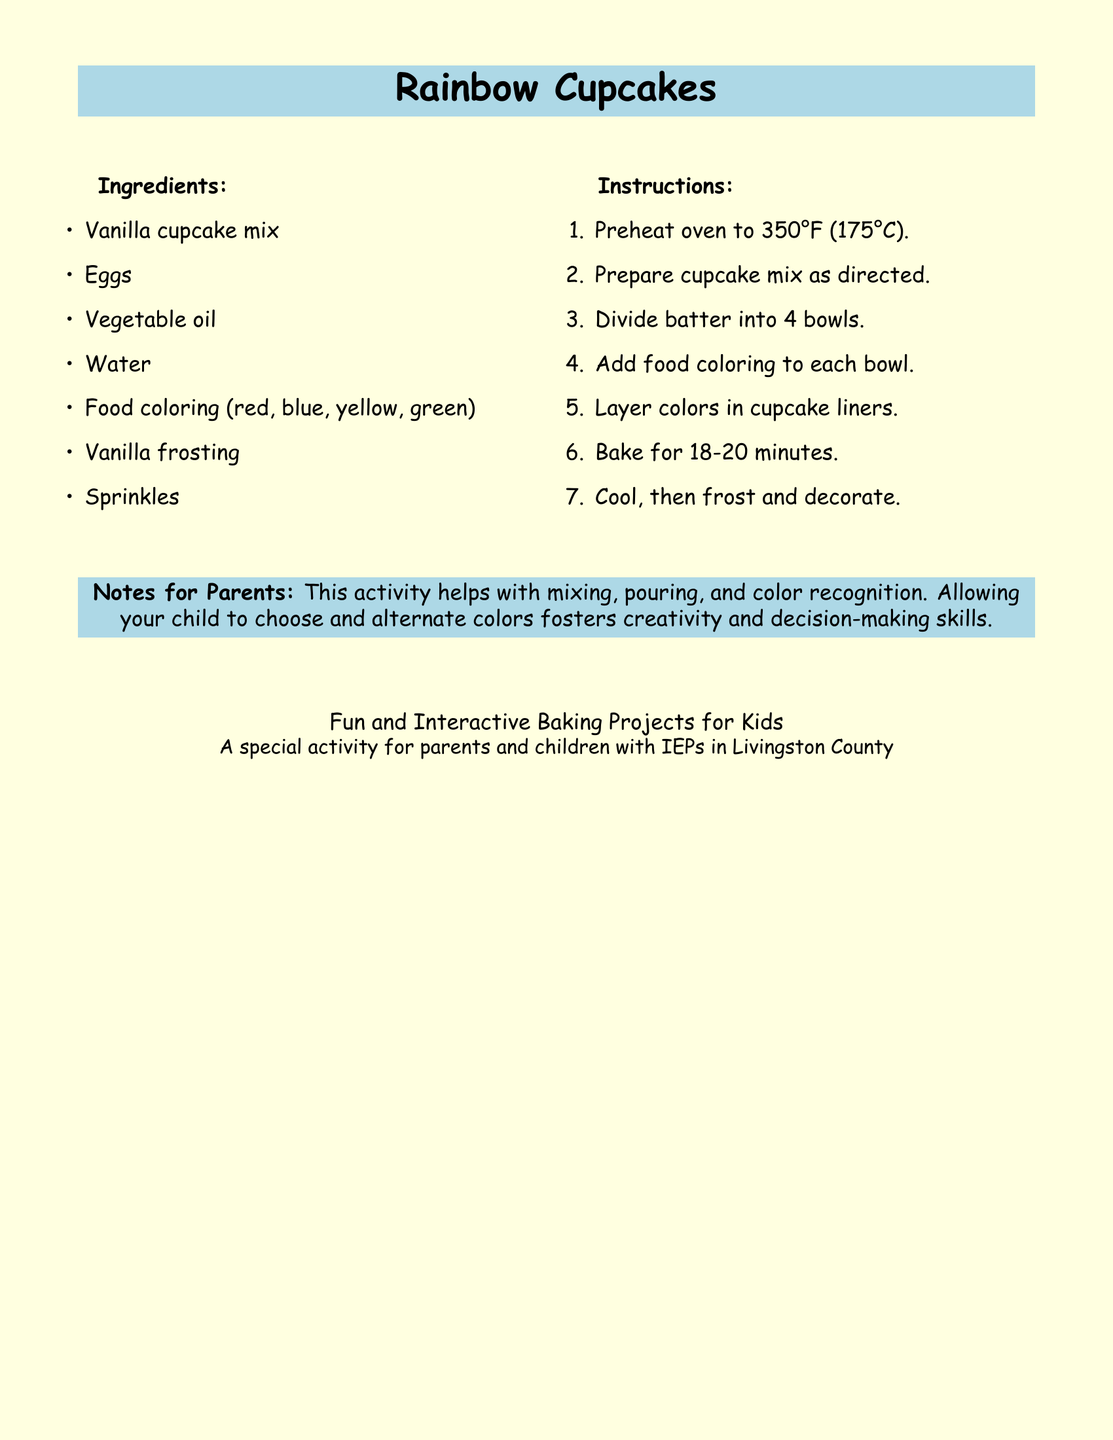What is the title of the recipe? The title of the recipe is prominently displayed in a larger font in the document.
Answer: Rainbow Cupcakes What temperature should the oven be preheated to? The preheating temperature is specified in the instructions section of the document.
Answer: 350°F How long should the cupcakes be baked? The baking time is indicated in the instructions list within the document.
Answer: 18-20 minutes What is one ingredient needed for the cupcakes? The ingredients are listed clearly within the document.
Answer: Vanilla cupcake mix What activity does this project help improve? This is mentioned in the notes for parents as an aspect of child development related to the activity.
Answer: Mixing, pouring, and color recognition How many different food coloring colors are needed? This information is given in the ingredients section, where various colors are listed.
Answer: Five What is one benefit of allowing children to choose colors? The notes for parents highlight the advantages of child involvement in decision-making.
Answer: Fosters creativity and decision-making skills What type of document is this? The structure and content indicate the type of document.
Answer: Recipe card 